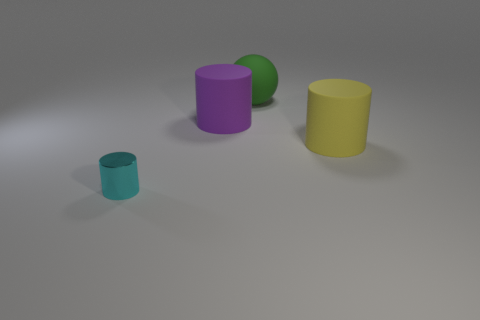Subtract all large yellow cylinders. How many cylinders are left? 2 Subtract all cyan cylinders. How many cylinders are left? 2 Subtract all spheres. How many objects are left? 3 Add 4 large cyan matte cylinders. How many objects exist? 8 Add 4 large purple matte objects. How many large purple matte objects exist? 5 Subtract 0 yellow blocks. How many objects are left? 4 Subtract 1 cylinders. How many cylinders are left? 2 Subtract all red cylinders. Subtract all red spheres. How many cylinders are left? 3 Subtract all cyan cubes. How many yellow cylinders are left? 1 Subtract all cyan objects. Subtract all cyan objects. How many objects are left? 2 